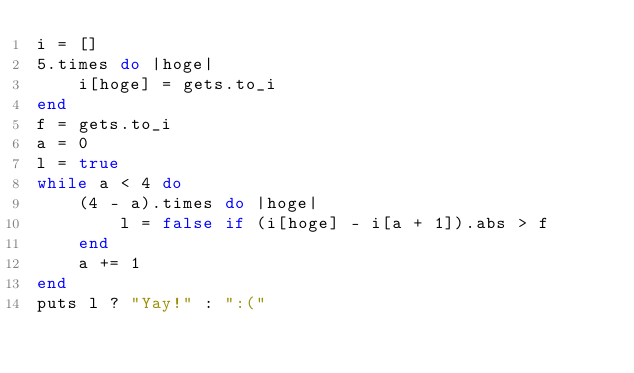<code> <loc_0><loc_0><loc_500><loc_500><_Ruby_>i = []
5.times do |hoge|
    i[hoge] = gets.to_i
end
f = gets.to_i
a = 0
l = true
while a < 4 do
    (4 - a).times do |hoge|
        l = false if (i[hoge] - i[a + 1]).abs > f
    end
    a += 1
end 
puts l ? "Yay!" : ":("</code> 